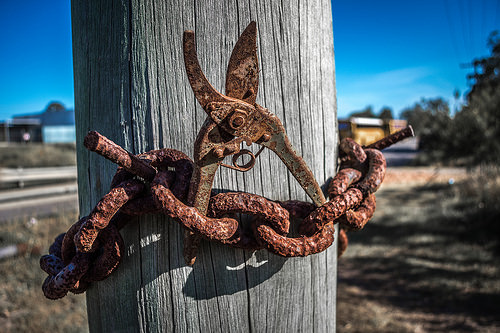<image>
Can you confirm if the shears is on the post? Yes. Looking at the image, I can see the shears is positioned on top of the post, with the post providing support. 